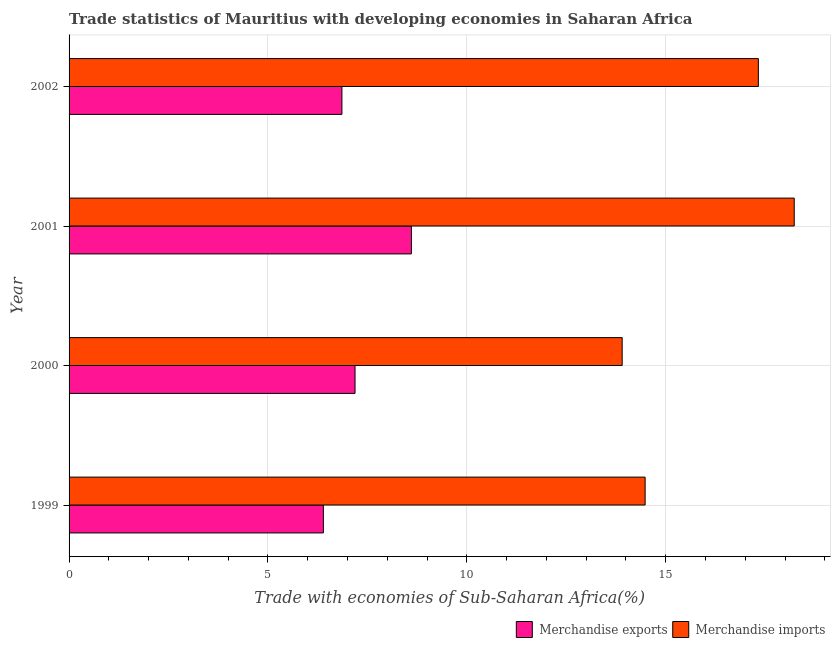How many different coloured bars are there?
Keep it short and to the point. 2. How many groups of bars are there?
Make the answer very short. 4. Are the number of bars per tick equal to the number of legend labels?
Make the answer very short. Yes. How many bars are there on the 4th tick from the top?
Ensure brevity in your answer.  2. How many bars are there on the 3rd tick from the bottom?
Provide a short and direct response. 2. In how many cases, is the number of bars for a given year not equal to the number of legend labels?
Make the answer very short. 0. What is the merchandise imports in 2001?
Keep it short and to the point. 18.23. Across all years, what is the maximum merchandise imports?
Give a very brief answer. 18.23. Across all years, what is the minimum merchandise imports?
Your response must be concise. 13.91. In which year was the merchandise imports maximum?
Give a very brief answer. 2001. What is the total merchandise exports in the graph?
Provide a short and direct response. 29.05. What is the difference between the merchandise exports in 1999 and that in 2002?
Your answer should be compact. -0.47. What is the difference between the merchandise imports in 2001 and the merchandise exports in 2000?
Your answer should be compact. 11.04. What is the average merchandise imports per year?
Your answer should be very brief. 15.99. In the year 2001, what is the difference between the merchandise imports and merchandise exports?
Offer a terse response. 9.62. What is the ratio of the merchandise exports in 2001 to that in 2002?
Provide a succinct answer. 1.25. Is the difference between the merchandise imports in 2001 and 2002 greater than the difference between the merchandise exports in 2001 and 2002?
Your answer should be very brief. No. What is the difference between the highest and the second highest merchandise exports?
Your answer should be compact. 1.42. What is the difference between the highest and the lowest merchandise imports?
Provide a short and direct response. 4.33. Is the sum of the merchandise imports in 2000 and 2002 greater than the maximum merchandise exports across all years?
Your answer should be very brief. Yes. What does the 2nd bar from the top in 2002 represents?
Offer a terse response. Merchandise exports. What does the 2nd bar from the bottom in 2001 represents?
Provide a succinct answer. Merchandise imports. How many bars are there?
Ensure brevity in your answer.  8. Are the values on the major ticks of X-axis written in scientific E-notation?
Your response must be concise. No. Does the graph contain any zero values?
Provide a short and direct response. No. Where does the legend appear in the graph?
Your answer should be compact. Bottom right. How are the legend labels stacked?
Your response must be concise. Horizontal. What is the title of the graph?
Make the answer very short. Trade statistics of Mauritius with developing economies in Saharan Africa. What is the label or title of the X-axis?
Provide a succinct answer. Trade with economies of Sub-Saharan Africa(%). What is the label or title of the Y-axis?
Keep it short and to the point. Year. What is the Trade with economies of Sub-Saharan Africa(%) in Merchandise exports in 1999?
Offer a very short reply. 6.39. What is the Trade with economies of Sub-Saharan Africa(%) of Merchandise imports in 1999?
Make the answer very short. 14.48. What is the Trade with economies of Sub-Saharan Africa(%) of Merchandise exports in 2000?
Give a very brief answer. 7.19. What is the Trade with economies of Sub-Saharan Africa(%) of Merchandise imports in 2000?
Ensure brevity in your answer.  13.91. What is the Trade with economies of Sub-Saharan Africa(%) of Merchandise exports in 2001?
Keep it short and to the point. 8.61. What is the Trade with economies of Sub-Saharan Africa(%) in Merchandise imports in 2001?
Offer a terse response. 18.23. What is the Trade with economies of Sub-Saharan Africa(%) of Merchandise exports in 2002?
Your answer should be very brief. 6.86. What is the Trade with economies of Sub-Saharan Africa(%) of Merchandise imports in 2002?
Your response must be concise. 17.33. Across all years, what is the maximum Trade with economies of Sub-Saharan Africa(%) in Merchandise exports?
Your answer should be very brief. 8.61. Across all years, what is the maximum Trade with economies of Sub-Saharan Africa(%) in Merchandise imports?
Ensure brevity in your answer.  18.23. Across all years, what is the minimum Trade with economies of Sub-Saharan Africa(%) in Merchandise exports?
Your answer should be very brief. 6.39. Across all years, what is the minimum Trade with economies of Sub-Saharan Africa(%) of Merchandise imports?
Give a very brief answer. 13.91. What is the total Trade with economies of Sub-Saharan Africa(%) in Merchandise exports in the graph?
Your answer should be compact. 29.05. What is the total Trade with economies of Sub-Saharan Africa(%) in Merchandise imports in the graph?
Provide a short and direct response. 63.95. What is the difference between the Trade with economies of Sub-Saharan Africa(%) in Merchandise exports in 1999 and that in 2000?
Ensure brevity in your answer.  -0.8. What is the difference between the Trade with economies of Sub-Saharan Africa(%) in Merchandise imports in 1999 and that in 2000?
Offer a terse response. 0.58. What is the difference between the Trade with economies of Sub-Saharan Africa(%) of Merchandise exports in 1999 and that in 2001?
Your response must be concise. -2.21. What is the difference between the Trade with economies of Sub-Saharan Africa(%) in Merchandise imports in 1999 and that in 2001?
Provide a short and direct response. -3.75. What is the difference between the Trade with economies of Sub-Saharan Africa(%) in Merchandise exports in 1999 and that in 2002?
Provide a short and direct response. -0.47. What is the difference between the Trade with economies of Sub-Saharan Africa(%) in Merchandise imports in 1999 and that in 2002?
Make the answer very short. -2.85. What is the difference between the Trade with economies of Sub-Saharan Africa(%) in Merchandise exports in 2000 and that in 2001?
Make the answer very short. -1.42. What is the difference between the Trade with economies of Sub-Saharan Africa(%) of Merchandise imports in 2000 and that in 2001?
Your response must be concise. -4.33. What is the difference between the Trade with economies of Sub-Saharan Africa(%) of Merchandise exports in 2000 and that in 2002?
Offer a very short reply. 0.33. What is the difference between the Trade with economies of Sub-Saharan Africa(%) in Merchandise imports in 2000 and that in 2002?
Keep it short and to the point. -3.42. What is the difference between the Trade with economies of Sub-Saharan Africa(%) in Merchandise exports in 2001 and that in 2002?
Provide a succinct answer. 1.75. What is the difference between the Trade with economies of Sub-Saharan Africa(%) of Merchandise imports in 2001 and that in 2002?
Offer a terse response. 0.9. What is the difference between the Trade with economies of Sub-Saharan Africa(%) in Merchandise exports in 1999 and the Trade with economies of Sub-Saharan Africa(%) in Merchandise imports in 2000?
Provide a short and direct response. -7.51. What is the difference between the Trade with economies of Sub-Saharan Africa(%) of Merchandise exports in 1999 and the Trade with economies of Sub-Saharan Africa(%) of Merchandise imports in 2001?
Offer a terse response. -11.84. What is the difference between the Trade with economies of Sub-Saharan Africa(%) of Merchandise exports in 1999 and the Trade with economies of Sub-Saharan Africa(%) of Merchandise imports in 2002?
Ensure brevity in your answer.  -10.94. What is the difference between the Trade with economies of Sub-Saharan Africa(%) in Merchandise exports in 2000 and the Trade with economies of Sub-Saharan Africa(%) in Merchandise imports in 2001?
Ensure brevity in your answer.  -11.04. What is the difference between the Trade with economies of Sub-Saharan Africa(%) of Merchandise exports in 2000 and the Trade with economies of Sub-Saharan Africa(%) of Merchandise imports in 2002?
Ensure brevity in your answer.  -10.14. What is the difference between the Trade with economies of Sub-Saharan Africa(%) in Merchandise exports in 2001 and the Trade with economies of Sub-Saharan Africa(%) in Merchandise imports in 2002?
Keep it short and to the point. -8.72. What is the average Trade with economies of Sub-Saharan Africa(%) in Merchandise exports per year?
Offer a very short reply. 7.26. What is the average Trade with economies of Sub-Saharan Africa(%) of Merchandise imports per year?
Offer a terse response. 15.99. In the year 1999, what is the difference between the Trade with economies of Sub-Saharan Africa(%) of Merchandise exports and Trade with economies of Sub-Saharan Africa(%) of Merchandise imports?
Give a very brief answer. -8.09. In the year 2000, what is the difference between the Trade with economies of Sub-Saharan Africa(%) in Merchandise exports and Trade with economies of Sub-Saharan Africa(%) in Merchandise imports?
Keep it short and to the point. -6.72. In the year 2001, what is the difference between the Trade with economies of Sub-Saharan Africa(%) of Merchandise exports and Trade with economies of Sub-Saharan Africa(%) of Merchandise imports?
Your answer should be very brief. -9.63. In the year 2002, what is the difference between the Trade with economies of Sub-Saharan Africa(%) of Merchandise exports and Trade with economies of Sub-Saharan Africa(%) of Merchandise imports?
Offer a terse response. -10.47. What is the ratio of the Trade with economies of Sub-Saharan Africa(%) in Merchandise exports in 1999 to that in 2000?
Provide a succinct answer. 0.89. What is the ratio of the Trade with economies of Sub-Saharan Africa(%) in Merchandise imports in 1999 to that in 2000?
Your answer should be compact. 1.04. What is the ratio of the Trade with economies of Sub-Saharan Africa(%) in Merchandise exports in 1999 to that in 2001?
Give a very brief answer. 0.74. What is the ratio of the Trade with economies of Sub-Saharan Africa(%) in Merchandise imports in 1999 to that in 2001?
Your response must be concise. 0.79. What is the ratio of the Trade with economies of Sub-Saharan Africa(%) of Merchandise exports in 1999 to that in 2002?
Offer a very short reply. 0.93. What is the ratio of the Trade with economies of Sub-Saharan Africa(%) in Merchandise imports in 1999 to that in 2002?
Your response must be concise. 0.84. What is the ratio of the Trade with economies of Sub-Saharan Africa(%) in Merchandise exports in 2000 to that in 2001?
Make the answer very short. 0.84. What is the ratio of the Trade with economies of Sub-Saharan Africa(%) of Merchandise imports in 2000 to that in 2001?
Provide a short and direct response. 0.76. What is the ratio of the Trade with economies of Sub-Saharan Africa(%) of Merchandise exports in 2000 to that in 2002?
Keep it short and to the point. 1.05. What is the ratio of the Trade with economies of Sub-Saharan Africa(%) in Merchandise imports in 2000 to that in 2002?
Keep it short and to the point. 0.8. What is the ratio of the Trade with economies of Sub-Saharan Africa(%) of Merchandise exports in 2001 to that in 2002?
Your answer should be very brief. 1.25. What is the ratio of the Trade with economies of Sub-Saharan Africa(%) of Merchandise imports in 2001 to that in 2002?
Offer a very short reply. 1.05. What is the difference between the highest and the second highest Trade with economies of Sub-Saharan Africa(%) of Merchandise exports?
Offer a terse response. 1.42. What is the difference between the highest and the second highest Trade with economies of Sub-Saharan Africa(%) in Merchandise imports?
Offer a terse response. 0.9. What is the difference between the highest and the lowest Trade with economies of Sub-Saharan Africa(%) in Merchandise exports?
Provide a short and direct response. 2.21. What is the difference between the highest and the lowest Trade with economies of Sub-Saharan Africa(%) of Merchandise imports?
Offer a terse response. 4.33. 